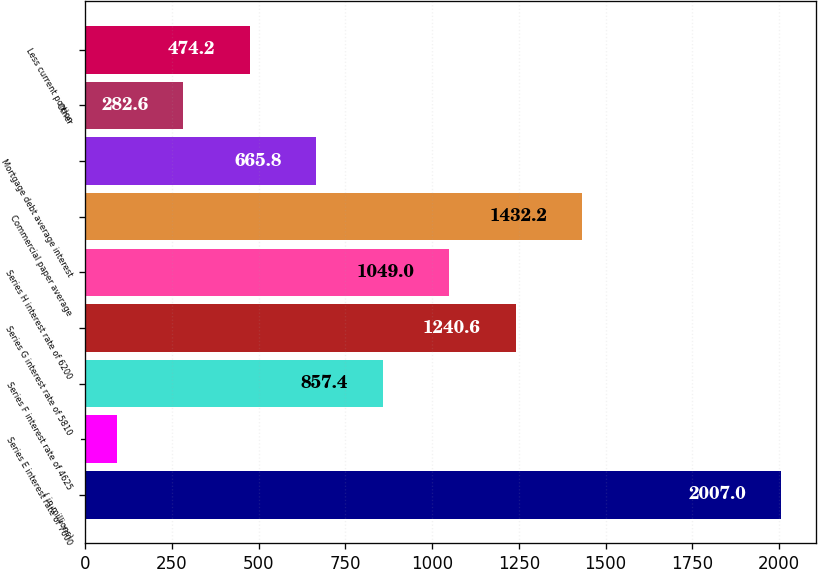<chart> <loc_0><loc_0><loc_500><loc_500><bar_chart><fcel>( in millions)<fcel>Series E interest rate of 7000<fcel>Series F interest rate of 4625<fcel>Series G interest rate of 5810<fcel>Series H interest rate of 6200<fcel>Commercial paper average<fcel>Mortgage debt average interest<fcel>Other<fcel>Less current portion<nl><fcel>2007<fcel>91<fcel>857.4<fcel>1240.6<fcel>1049<fcel>1432.2<fcel>665.8<fcel>282.6<fcel>474.2<nl></chart> 